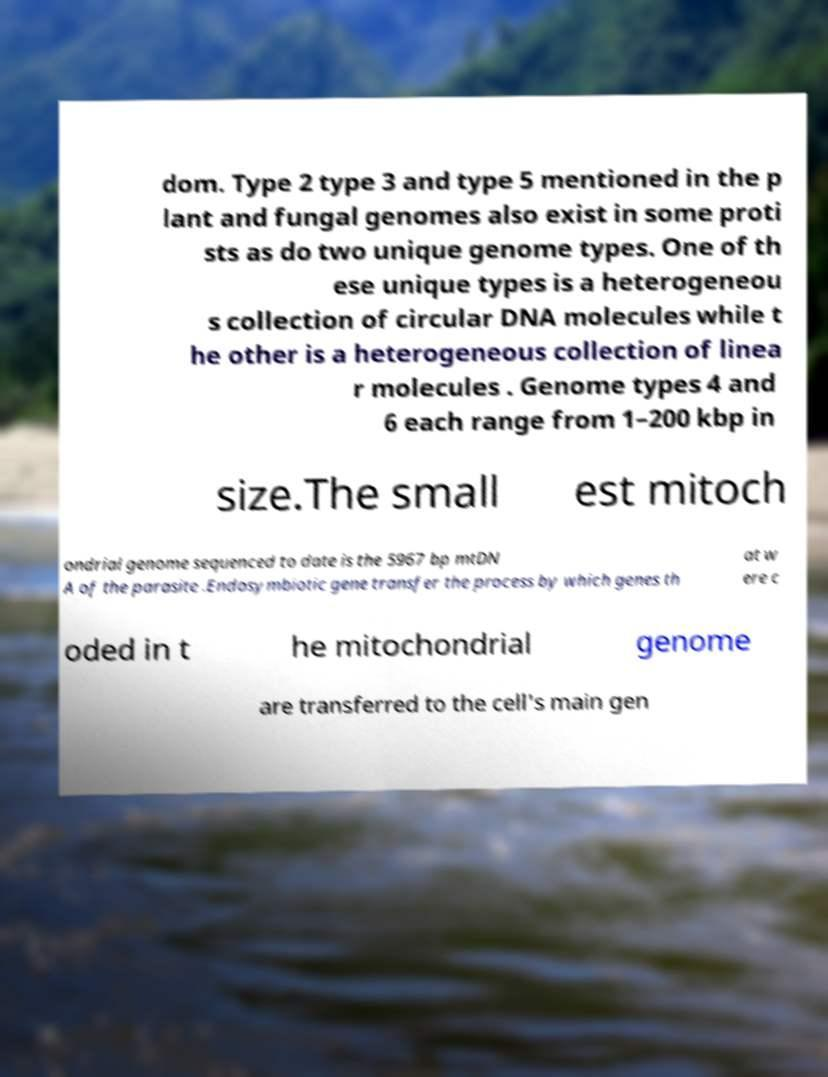Please identify and transcribe the text found in this image. dom. Type 2 type 3 and type 5 mentioned in the p lant and fungal genomes also exist in some proti sts as do two unique genome types. One of th ese unique types is a heterogeneou s collection of circular DNA molecules while t he other is a heterogeneous collection of linea r molecules . Genome types 4 and 6 each range from 1–200 kbp in size.The small est mitoch ondrial genome sequenced to date is the 5967 bp mtDN A of the parasite .Endosymbiotic gene transfer the process by which genes th at w ere c oded in t he mitochondrial genome are transferred to the cell's main gen 